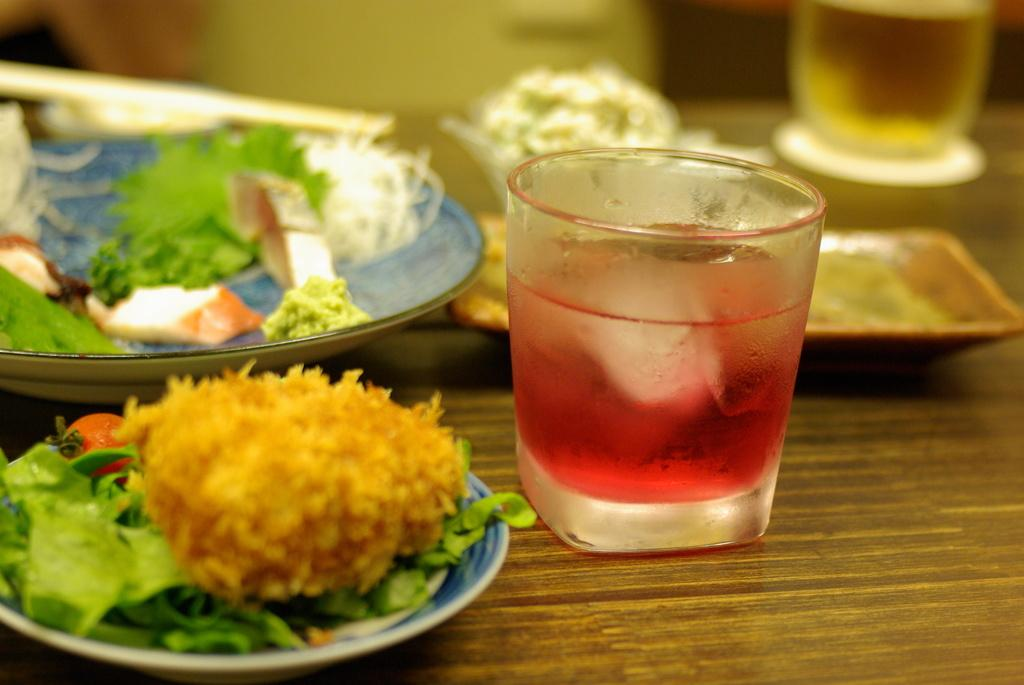What is on the plates in the image? There is food on plates in the image. What is in the glasses in the image? There is drink in glasses in the image. Where are the plates and glasses located? The plates and glasses are on a table. Can you describe the background of the image? The background of the image is blurry. What type of dress is being worn by the sponge in the image? There is no sponge present in the image, and therefore no dress can be associated with it. 